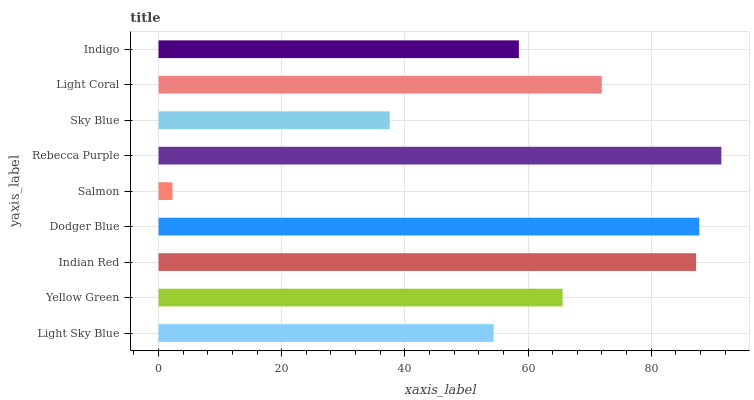Is Salmon the minimum?
Answer yes or no. Yes. Is Rebecca Purple the maximum?
Answer yes or no. Yes. Is Yellow Green the minimum?
Answer yes or no. No. Is Yellow Green the maximum?
Answer yes or no. No. Is Yellow Green greater than Light Sky Blue?
Answer yes or no. Yes. Is Light Sky Blue less than Yellow Green?
Answer yes or no. Yes. Is Light Sky Blue greater than Yellow Green?
Answer yes or no. No. Is Yellow Green less than Light Sky Blue?
Answer yes or no. No. Is Yellow Green the high median?
Answer yes or no. Yes. Is Yellow Green the low median?
Answer yes or no. Yes. Is Indian Red the high median?
Answer yes or no. No. Is Salmon the low median?
Answer yes or no. No. 